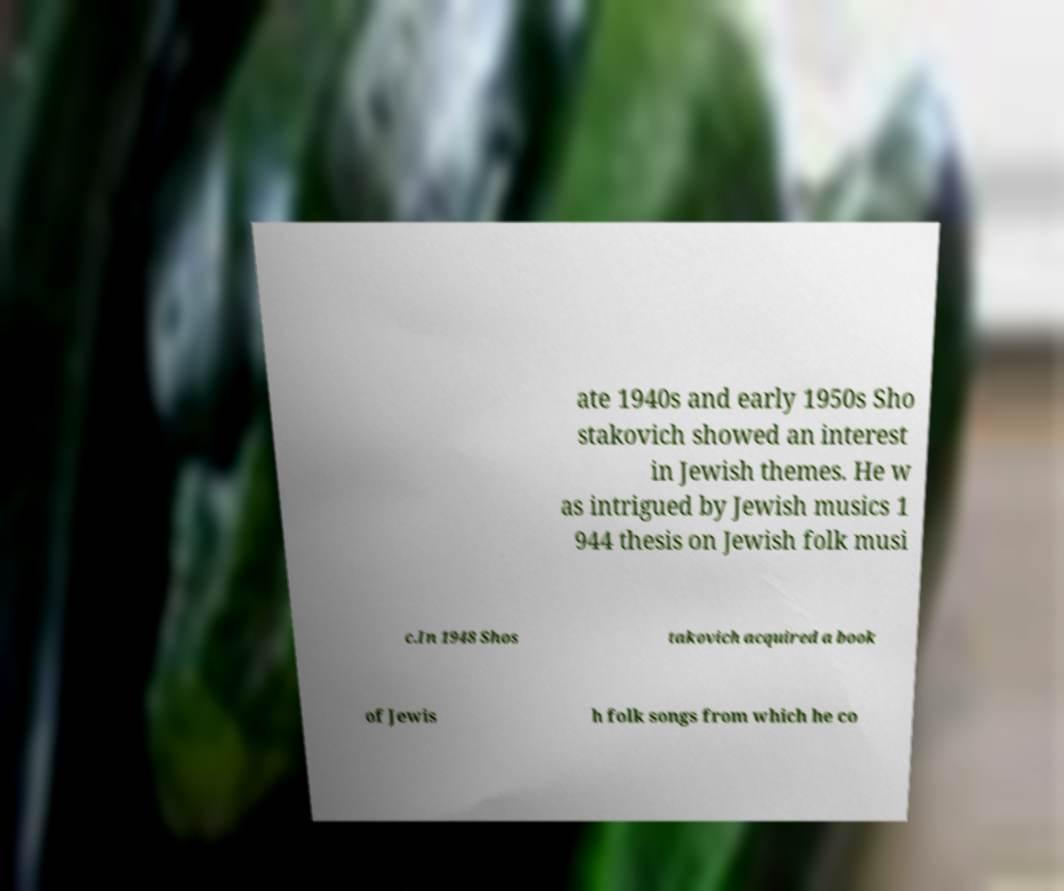Can you accurately transcribe the text from the provided image for me? ate 1940s and early 1950s Sho stakovich showed an interest in Jewish themes. He w as intrigued by Jewish musics 1 944 thesis on Jewish folk musi c.In 1948 Shos takovich acquired a book of Jewis h folk songs from which he co 